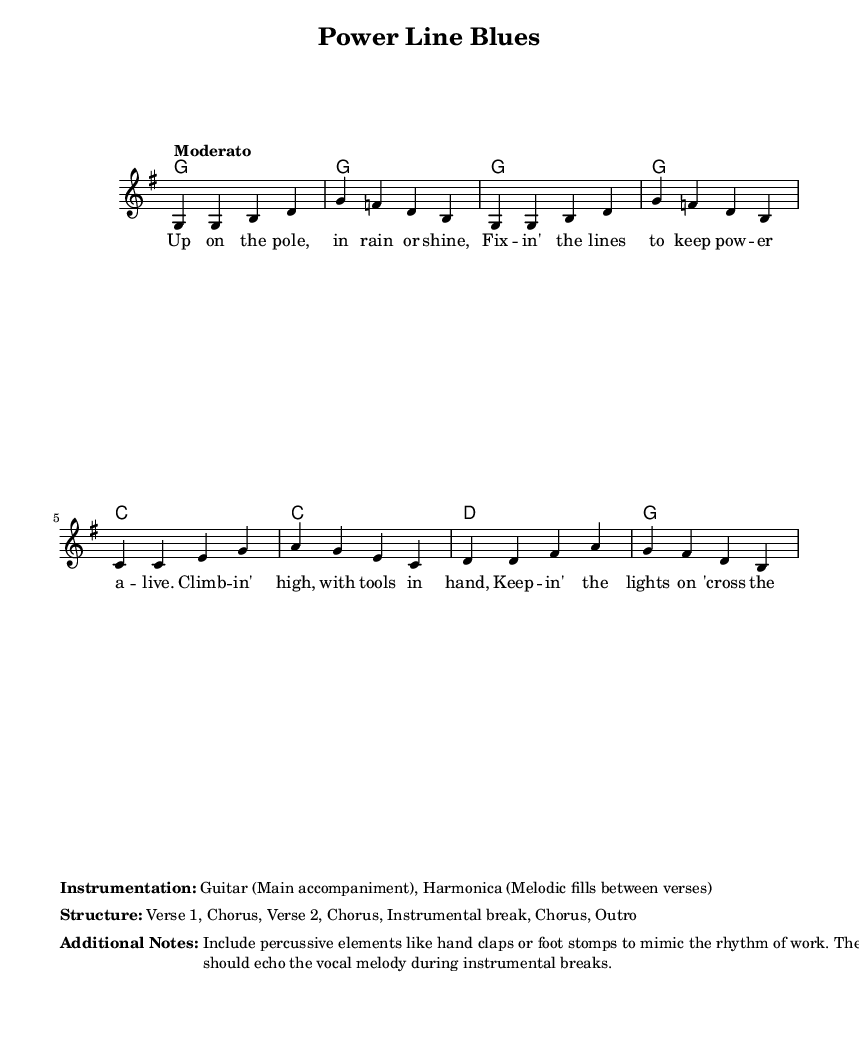What is the key signature of this music? The key signature is indicated at the beginning of the score and shows one sharp, which means it is G major.
Answer: G major What is the time signature of this music? The time signature is found at the start of the score and shows a 4 above a 4, signifying 4 beats per measure.
Answer: 4/4 What is the tempo marking for this piece? The tempo marking is found in the global context section and states "Moderato," indicating a moderate speed.
Answer: Moderato How many verses are in the structure of the song? The structure section lists the order of the song components, stating there are two verses.
Answer: Two What instrument is used for the main accompaniment? The instrumentation section specifies that the guitar is the main accompaniment for this song.
Answer: Guitar What rhythmic elements should be included in the performance? The additional notes section suggests including percussive elements like hand claps or foot stomps to enhance the rhythm.
Answer: Hand claps, foot stomps In what context is the harmonica used in this piece? The instrumentation section describes that the harmonica plays melodic fills between verses, echoing the vocal melody.
Answer: Melodic fills between verses 